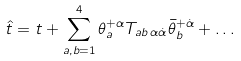Convert formula to latex. <formula><loc_0><loc_0><loc_500><loc_500>\hat { t } = t + \sum ^ { 4 } _ { a , b = 1 } \theta ^ { + \alpha } _ { a } T _ { a b \, \alpha \dot { \alpha } } \bar { \theta } ^ { + \dot { \alpha } } _ { b } + \dots</formula> 